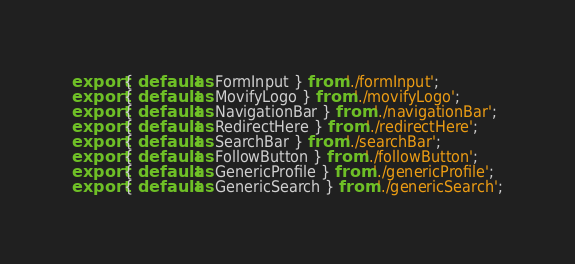Convert code to text. <code><loc_0><loc_0><loc_500><loc_500><_JavaScript_>export { default as FormInput } from './formInput';
export { default as MovifyLogo } from './movifyLogo';
export { default as NavigationBar } from './navigationBar';
export { default as RedirectHere } from './redirectHere';
export { default as SearchBar } from './searchBar';
export { default as FollowButton } from './followButton';
export { default as GenericProfile } from './genericProfile';
export { default as GenericSearch } from './genericSearch';</code> 